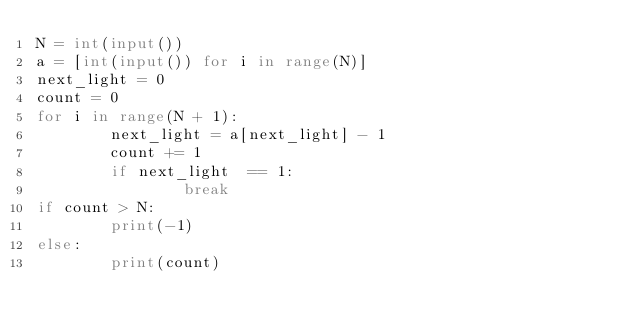<code> <loc_0><loc_0><loc_500><loc_500><_Python_>N = int(input())
a = [int(input()) for i in range(N)]
next_light = 0 
count = 0 
for i in range(N + 1): 
        next_light = a[next_light] - 1 
        count += 1
        if next_light  == 1:
                break
if count > N:
        print(-1)
else:
        print(count)</code> 